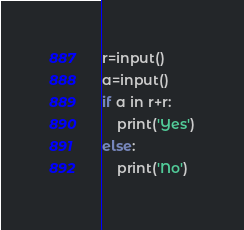<code> <loc_0><loc_0><loc_500><loc_500><_Python_>r=input()
a=input()
if a in r+r:
	print('Yes')
else:
	print('No')
</code> 